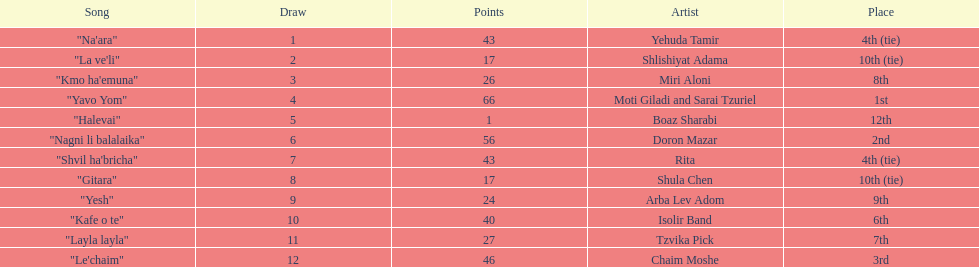Compare draws, which had the least amount of points? Boaz Sharabi. 